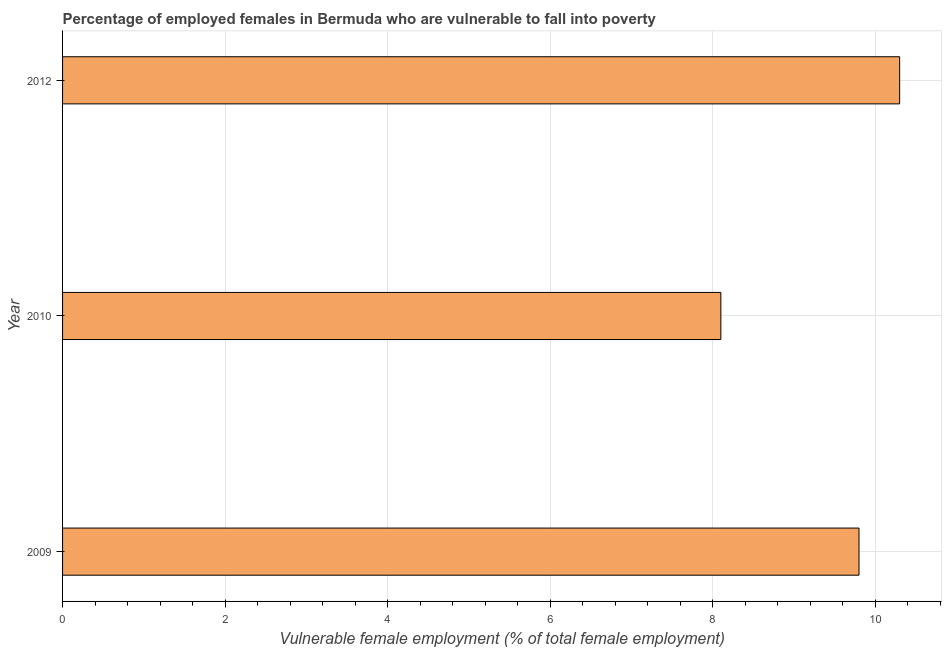What is the title of the graph?
Offer a terse response. Percentage of employed females in Bermuda who are vulnerable to fall into poverty. What is the label or title of the X-axis?
Keep it short and to the point. Vulnerable female employment (% of total female employment). What is the percentage of employed females who are vulnerable to fall into poverty in 2012?
Provide a short and direct response. 10.3. Across all years, what is the maximum percentage of employed females who are vulnerable to fall into poverty?
Keep it short and to the point. 10.3. Across all years, what is the minimum percentage of employed females who are vulnerable to fall into poverty?
Your answer should be compact. 8.1. What is the sum of the percentage of employed females who are vulnerable to fall into poverty?
Your answer should be very brief. 28.2. What is the difference between the percentage of employed females who are vulnerable to fall into poverty in 2009 and 2012?
Your answer should be compact. -0.5. What is the median percentage of employed females who are vulnerable to fall into poverty?
Your response must be concise. 9.8. What is the ratio of the percentage of employed females who are vulnerable to fall into poverty in 2010 to that in 2012?
Provide a succinct answer. 0.79. Is the sum of the percentage of employed females who are vulnerable to fall into poverty in 2009 and 2010 greater than the maximum percentage of employed females who are vulnerable to fall into poverty across all years?
Keep it short and to the point. Yes. In how many years, is the percentage of employed females who are vulnerable to fall into poverty greater than the average percentage of employed females who are vulnerable to fall into poverty taken over all years?
Offer a very short reply. 2. How many bars are there?
Offer a very short reply. 3. How many years are there in the graph?
Offer a terse response. 3. What is the difference between two consecutive major ticks on the X-axis?
Your response must be concise. 2. Are the values on the major ticks of X-axis written in scientific E-notation?
Provide a short and direct response. No. What is the Vulnerable female employment (% of total female employment) in 2009?
Provide a short and direct response. 9.8. What is the Vulnerable female employment (% of total female employment) of 2010?
Offer a very short reply. 8.1. What is the Vulnerable female employment (% of total female employment) of 2012?
Make the answer very short. 10.3. What is the difference between the Vulnerable female employment (% of total female employment) in 2010 and 2012?
Provide a short and direct response. -2.2. What is the ratio of the Vulnerable female employment (% of total female employment) in 2009 to that in 2010?
Ensure brevity in your answer.  1.21. What is the ratio of the Vulnerable female employment (% of total female employment) in 2009 to that in 2012?
Offer a terse response. 0.95. What is the ratio of the Vulnerable female employment (% of total female employment) in 2010 to that in 2012?
Your answer should be very brief. 0.79. 